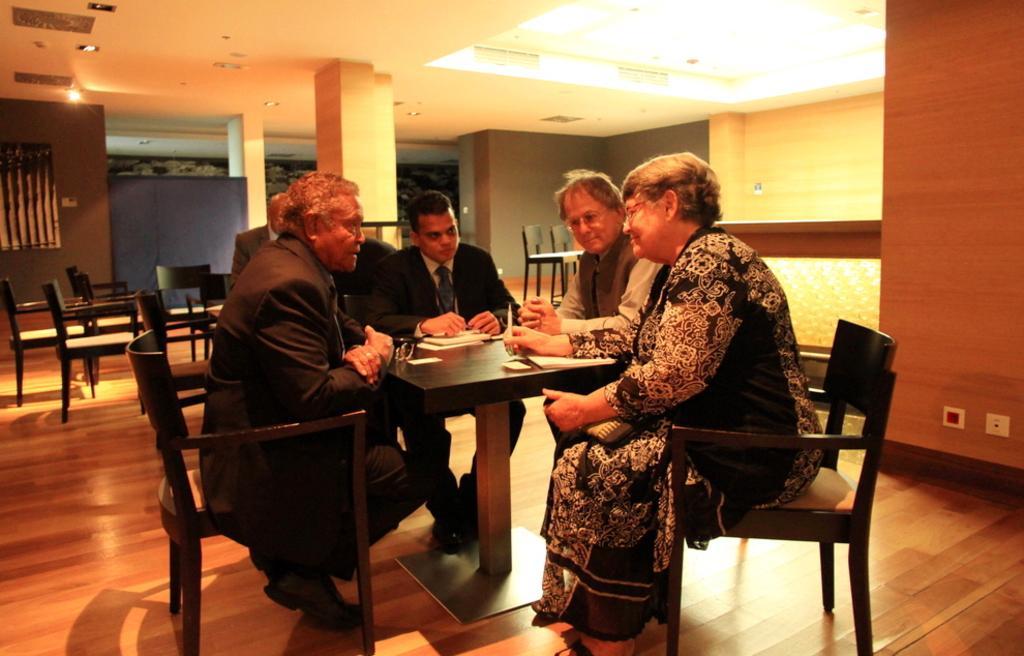Can you describe this image briefly? In this image I can see number of people are sitting on chairs. In the background I can see few more chairs. 